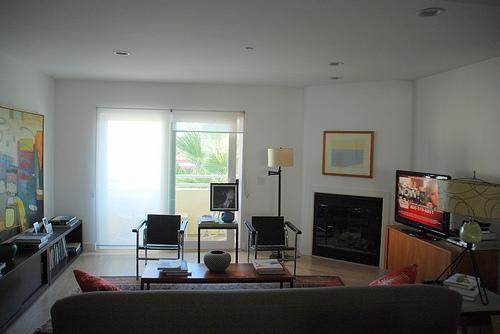How many fires are there outside of the fireplace?
Give a very brief answer. 0. 